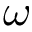Convert formula to latex. <formula><loc_0><loc_0><loc_500><loc_500>\omega</formula> 